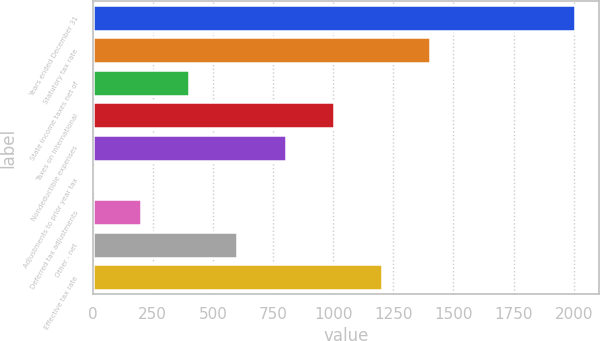Convert chart to OTSL. <chart><loc_0><loc_0><loc_500><loc_500><bar_chart><fcel>Years ended December 31<fcel>Statutory tax rate<fcel>State income taxes net of<fcel>Taxes on international<fcel>Nondeductible expenses<fcel>Adjustments to prior year tax<fcel>Deferred tax adjustments<fcel>Other - net<fcel>Effective tax rate<nl><fcel>2006<fcel>1404.29<fcel>401.44<fcel>1003.15<fcel>802.58<fcel>0.3<fcel>200.87<fcel>602.01<fcel>1203.72<nl></chart> 